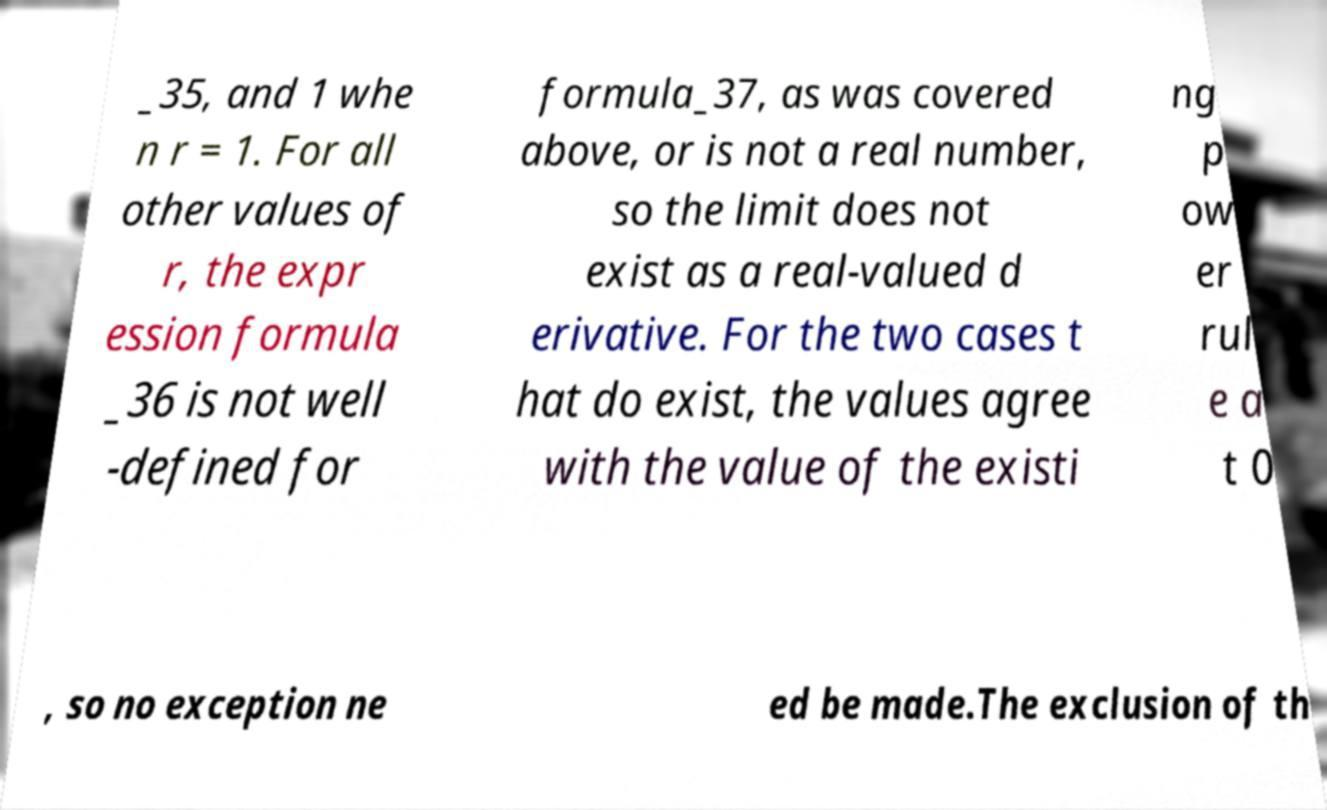Please read and relay the text visible in this image. What does it say? _35, and 1 whe n r = 1. For all other values of r, the expr ession formula _36 is not well -defined for formula_37, as was covered above, or is not a real number, so the limit does not exist as a real-valued d erivative. For the two cases t hat do exist, the values agree with the value of the existi ng p ow er rul e a t 0 , so no exception ne ed be made.The exclusion of th 